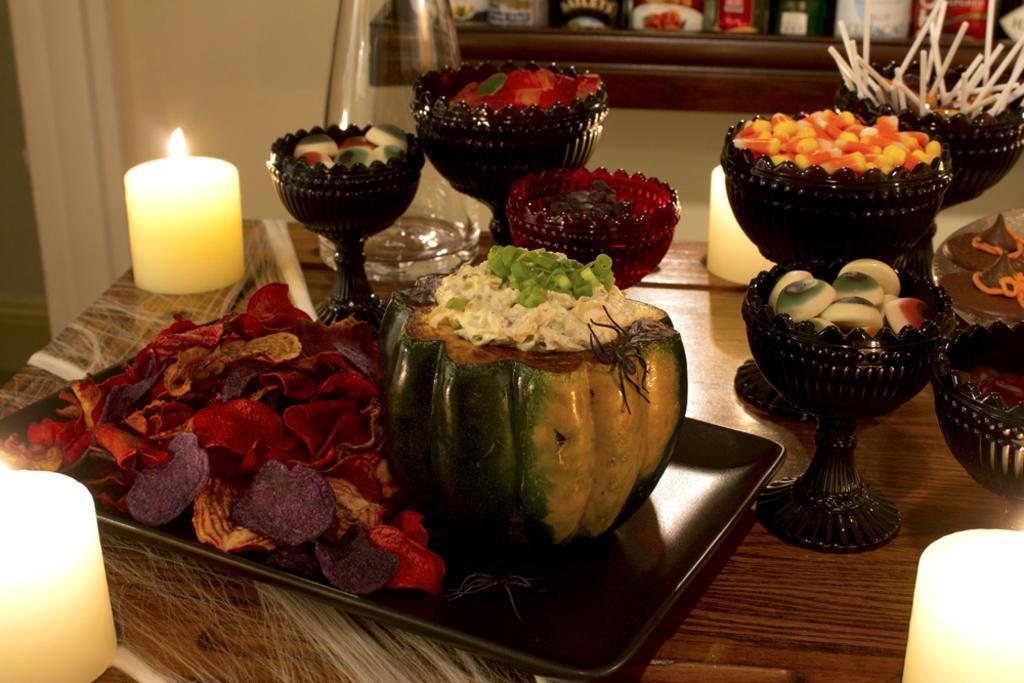Could you give a brief overview of what you see in this image? In this picture there is a table on which there is a tray which had coconut with pudding on above of it and there are some flower petals and beside the tree there are jars filled with food and capsules and at the left side over corner there are two on either sides. 